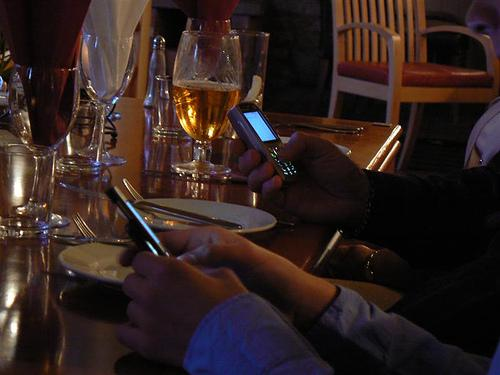Question: where are the people?
Choices:
A. On the couch.
B. In a swimming pool.
C. In a car.
D. At a table.
Answer with the letter. Answer: D Question: what is on?
Choices:
A. The phones.
B. The lights.
C. The television.
D. The computer.
Answer with the letter. Answer: A Question: where are the phones?
Choices:
A. On the table.
B. On the bed.
C. Under the counter.
D. In their hands.
Answer with the letter. Answer: D Question: what color is the table?
Choices:
A. Green.
B. Brown.
C. Yellow.
D. Blue.
Answer with the letter. Answer: B Question: what is on the table?
Choices:
A. Desserts.
B. Pizzas.
C. Plates.
D. Drinks.
Answer with the letter. Answer: D 